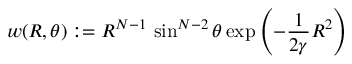<formula> <loc_0><loc_0><loc_500><loc_500>w ( R , \theta ) \colon = R ^ { N - 1 } \, \sin ^ { N - 2 } \theta \exp \left ( - \frac { 1 } { 2 \gamma } R ^ { 2 } \right )</formula> 